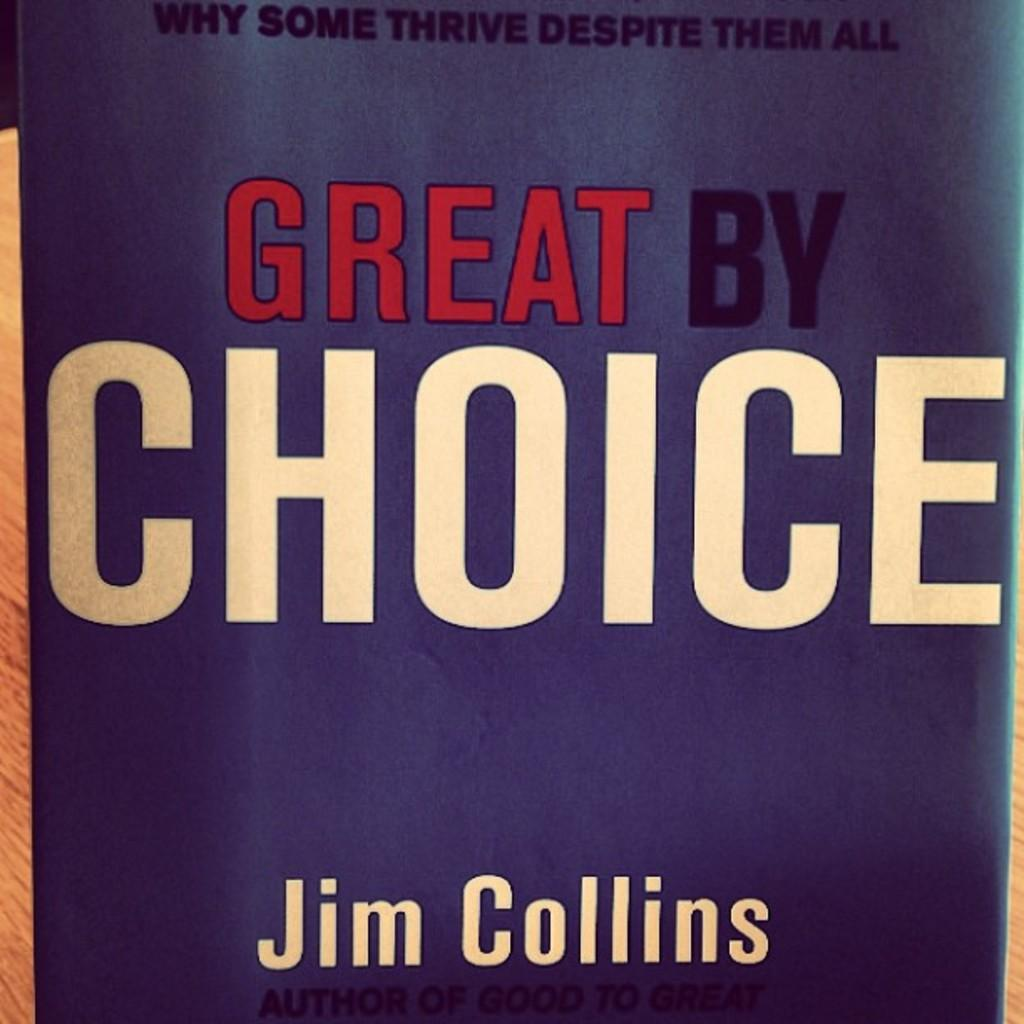What object is present in the image? There is a book in the image. Can you describe the specific part of the book that is visible? The image shows the front page of the book. What can be seen on the front page of the book? There is text visible on the front page of the book. What type of can is visible on the front page of the book? There is no can visible on the front page of the book; it only shows text. How does the daughter interact with the book in the image? There is no daughter present in the image, so it is not possible to describe any interaction with the book. 